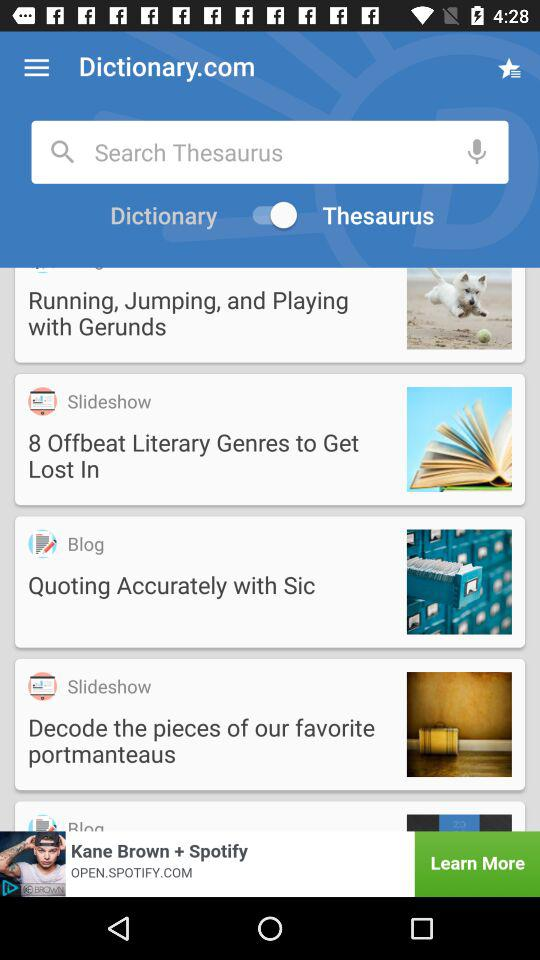What is the application name? The application name is "Dictionary.com". 